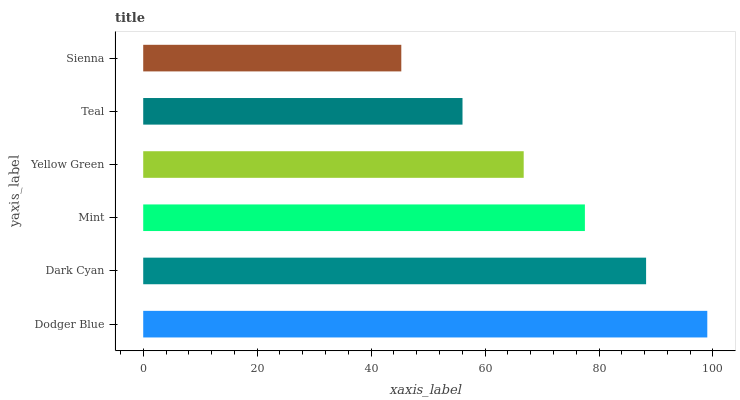Is Sienna the minimum?
Answer yes or no. Yes. Is Dodger Blue the maximum?
Answer yes or no. Yes. Is Dark Cyan the minimum?
Answer yes or no. No. Is Dark Cyan the maximum?
Answer yes or no. No. Is Dodger Blue greater than Dark Cyan?
Answer yes or no. Yes. Is Dark Cyan less than Dodger Blue?
Answer yes or no. Yes. Is Dark Cyan greater than Dodger Blue?
Answer yes or no. No. Is Dodger Blue less than Dark Cyan?
Answer yes or no. No. Is Mint the high median?
Answer yes or no. Yes. Is Yellow Green the low median?
Answer yes or no. Yes. Is Teal the high median?
Answer yes or no. No. Is Teal the low median?
Answer yes or no. No. 